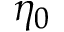Convert formula to latex. <formula><loc_0><loc_0><loc_500><loc_500>\eta _ { 0 }</formula> 